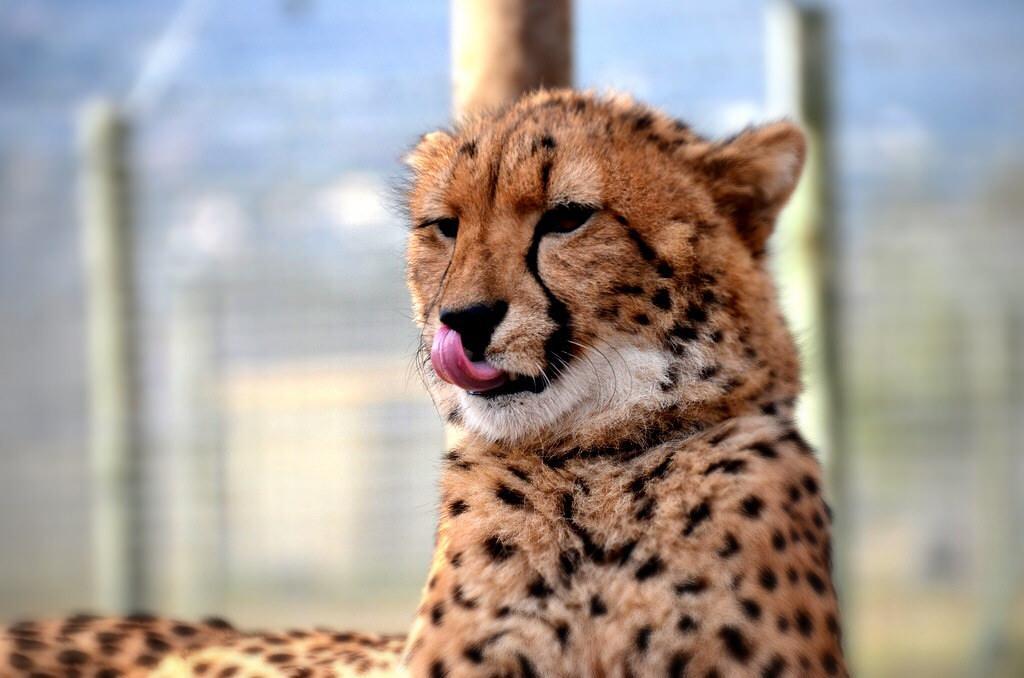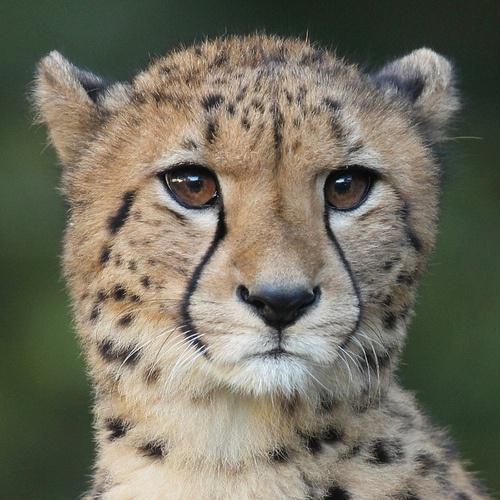The first image is the image on the left, the second image is the image on the right. Evaluate the accuracy of this statement regarding the images: "The left image includes at least one cheetah in a reclining pose with both its front paws forward, and the right image includes a cheetah with a blood-drenched muzzle.". Is it true? Answer yes or no. No. The first image is the image on the left, the second image is the image on the right. Given the left and right images, does the statement "At least one cheetah has blood around its mouth." hold true? Answer yes or no. No. 